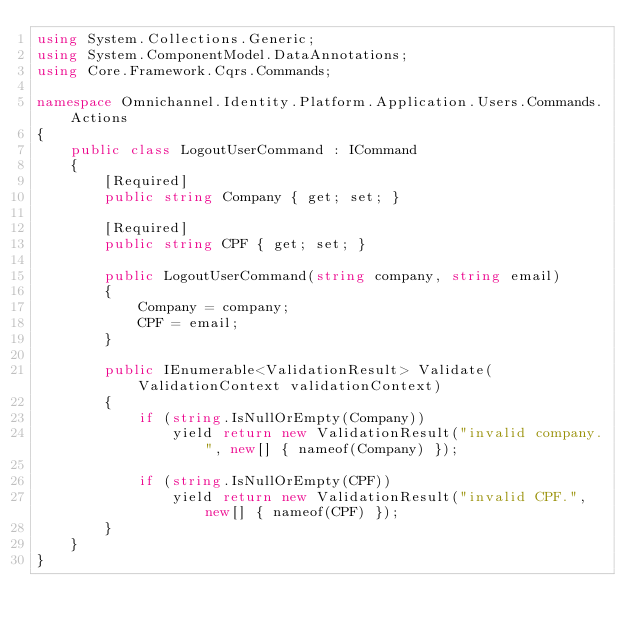<code> <loc_0><loc_0><loc_500><loc_500><_C#_>using System.Collections.Generic;
using System.ComponentModel.DataAnnotations;
using Core.Framework.Cqrs.Commands;

namespace Omnichannel.Identity.Platform.Application.Users.Commands.Actions
{
    public class LogoutUserCommand : ICommand
    {
        [Required]
        public string Company { get; set; }

        [Required]
        public string CPF { get; set; }

        public LogoutUserCommand(string company, string email)
        {
            Company = company;
            CPF = email;
        }

        public IEnumerable<ValidationResult> Validate(ValidationContext validationContext)
        {
            if (string.IsNullOrEmpty(Company))
                yield return new ValidationResult("invalid company.", new[] { nameof(Company) });

            if (string.IsNullOrEmpty(CPF))
                yield return new ValidationResult("invalid CPF.", new[] { nameof(CPF) });
        }
    }
}</code> 